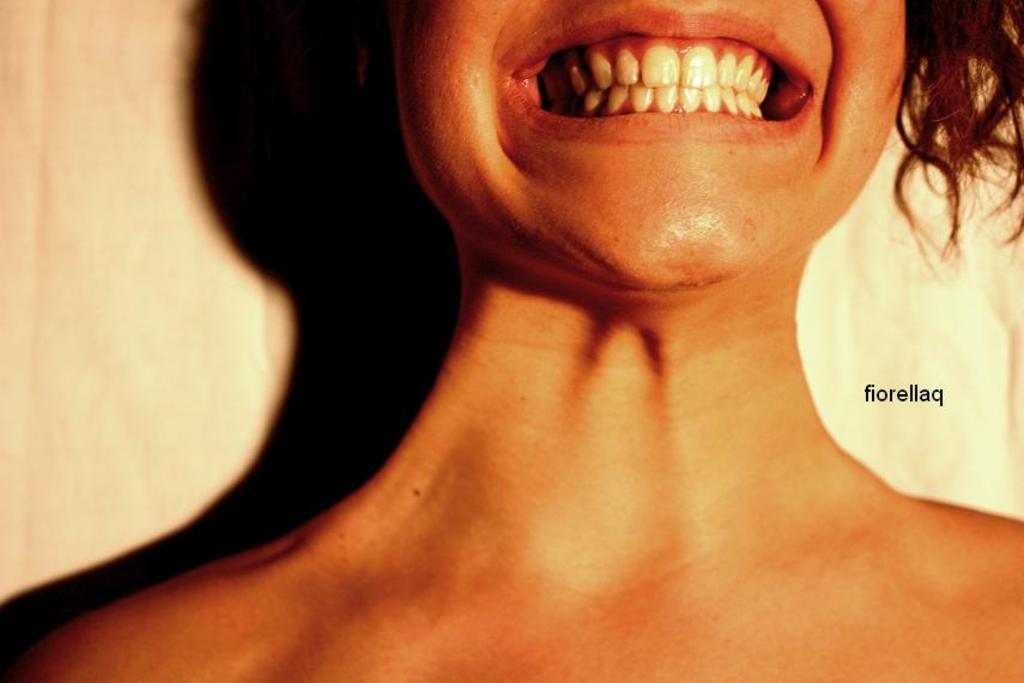Who or what is the main subject in the image? There is a person in the image. What else can be seen on the right side of the image? There is text on the right side of the image. What is the background of the image? The background of the image features a plane. How many sisters does the person in the image have? There is no information about the person's family members in the image, so we cannot determine the number of sisters they have. 